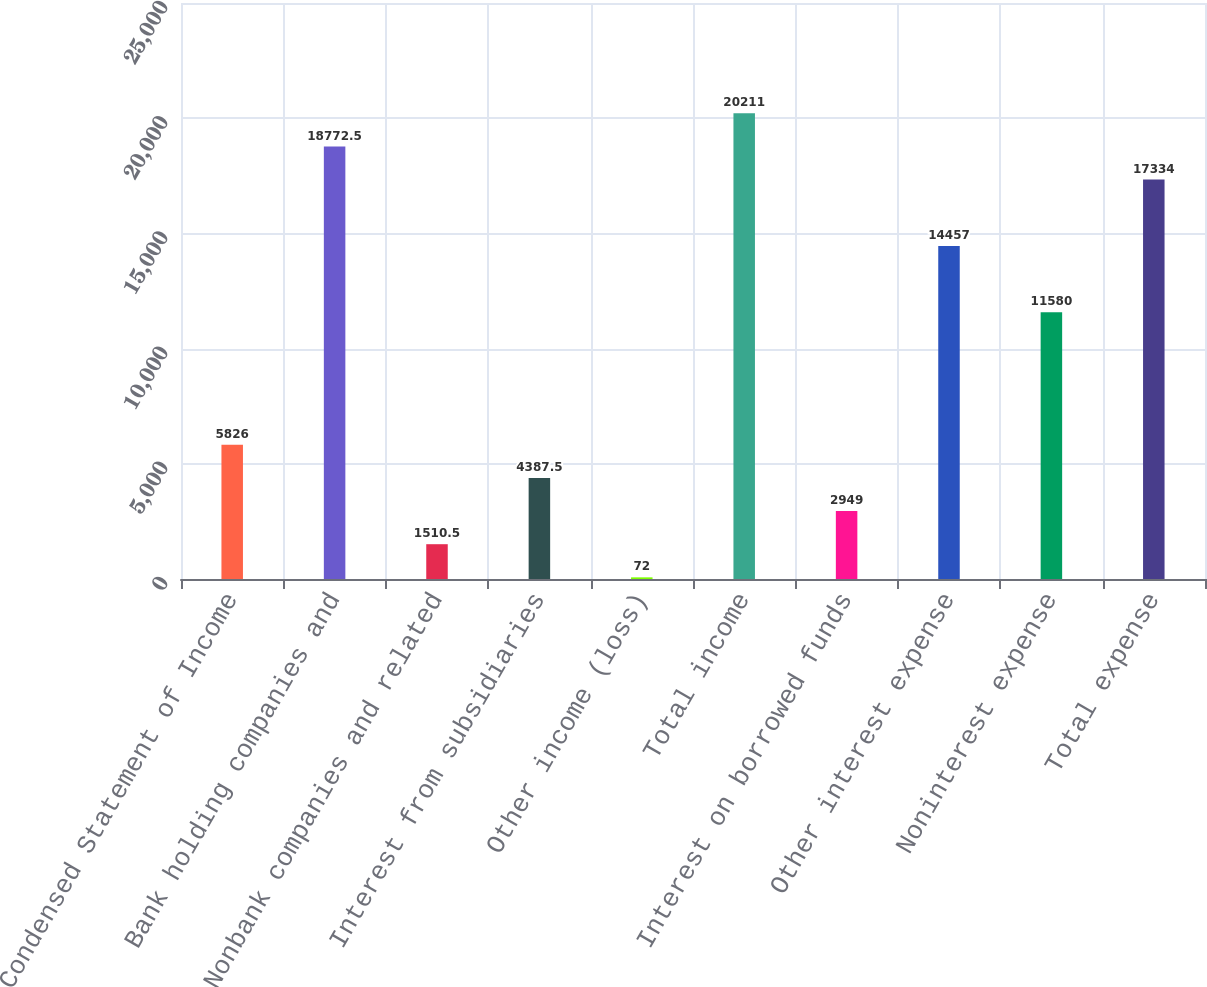<chart> <loc_0><loc_0><loc_500><loc_500><bar_chart><fcel>Condensed Statement of Income<fcel>Bank holding companies and<fcel>Nonbank companies and related<fcel>Interest from subsidiaries<fcel>Other income (loss)<fcel>Total income<fcel>Interest on borrowed funds<fcel>Other interest expense<fcel>Noninterest expense<fcel>Total expense<nl><fcel>5826<fcel>18772.5<fcel>1510.5<fcel>4387.5<fcel>72<fcel>20211<fcel>2949<fcel>14457<fcel>11580<fcel>17334<nl></chart> 